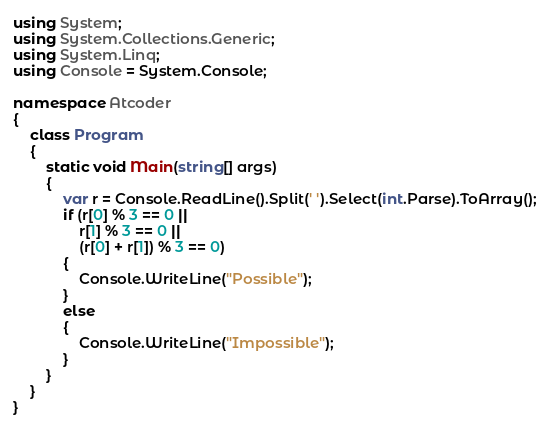<code> <loc_0><loc_0><loc_500><loc_500><_C#_>using System;
using System.Collections.Generic;
using System.Linq;
using Console = System.Console;

namespace Atcoder
{
    class Program
    {
        static void Main(string[] args)
        {
            var r = Console.ReadLine().Split(' ').Select(int.Parse).ToArray();
            if (r[0] % 3 == 0 ||
                r[1] % 3 == 0 ||
                (r[0] + r[1]) % 3 == 0)
            {
                Console.WriteLine("Possible");
            }
            else
            {
                Console.WriteLine("Impossible");
            }
        }
    }
}</code> 